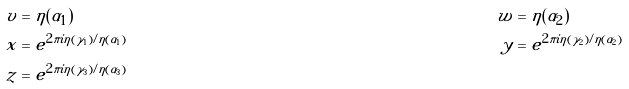Convert formula to latex. <formula><loc_0><loc_0><loc_500><loc_500>v & = \eta ( \alpha _ { 1 } ) & w & = \eta ( \alpha _ { 2 } ) \\ x & = e ^ { 2 \pi i \eta ( \gamma _ { 1 } ) / \eta ( \alpha _ { 1 } ) } & y & = e ^ { 2 \pi i \eta ( \gamma _ { 2 } ) / \eta ( \alpha _ { 2 } ) } \\ z & = e ^ { 2 \pi i \eta ( \gamma _ { 3 } ) / \eta ( \alpha _ { 3 } ) }</formula> 